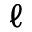<formula> <loc_0><loc_0><loc_500><loc_500>\ell</formula> 